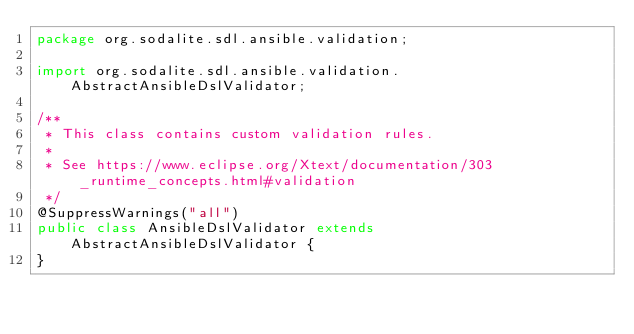<code> <loc_0><loc_0><loc_500><loc_500><_Java_>package org.sodalite.sdl.ansible.validation;

import org.sodalite.sdl.ansible.validation.AbstractAnsibleDslValidator;

/**
 * This class contains custom validation rules.
 * 
 * See https://www.eclipse.org/Xtext/documentation/303_runtime_concepts.html#validation
 */
@SuppressWarnings("all")
public class AnsibleDslValidator extends AbstractAnsibleDslValidator {
}
</code> 